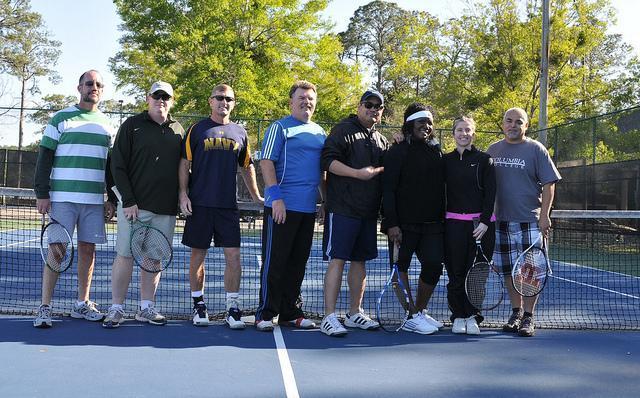How many boys are wearing glasses?
Give a very brief answer. 3. How many people are there?
Give a very brief answer. 8. How many buses are double-decker buses?
Give a very brief answer. 0. 